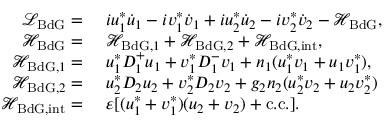<formula> <loc_0><loc_0><loc_500><loc_500>\begin{array} { r l } { \mathcal { L } _ { B d G } = } & { \ i u _ { 1 } ^ { * } \dot { u } _ { 1 } - i v _ { 1 } ^ { * } \dot { v } _ { 1 } + i u _ { 2 } ^ { * } \dot { u } _ { 2 } - i v _ { 2 } ^ { * } \dot { v } _ { 2 } - \mathcal { H } _ { B d G } , } \\ { \mathcal { H } _ { B d G } = } & { \ \mathcal { H } _ { B d G , 1 } + \mathcal { H } _ { B d G , 2 } + \mathcal { H } _ { B d G , i n t } , } \\ { \mathcal { H } _ { B d G , 1 } = } & { \ u _ { 1 } ^ { * } D _ { 1 } ^ { + } u _ { 1 } + v _ { 1 } ^ { * } D _ { 1 } ^ { - } v _ { 1 } + n _ { 1 } ( u _ { 1 } ^ { * } v _ { 1 } + u _ { 1 } v _ { 1 } ^ { * } ) , } \\ { \mathcal { H } _ { B d G , 2 } = } & { \ u _ { 2 } ^ { * } D _ { 2 } u _ { 2 } + v _ { 2 } ^ { * } D _ { 2 } v _ { 2 } + g _ { 2 } n _ { 2 } ( u _ { 2 } ^ { * } v _ { 2 } + u _ { 2 } v _ { 2 } ^ { * } ) } \\ { \mathcal { H } _ { B d G , i n t } = } & { \ \varepsilon [ ( u _ { 1 } ^ { * } + v _ { 1 } ^ { * } ) ( u _ { 2 } + v _ { 2 } ) + c . c . ] . } \end{array}</formula> 